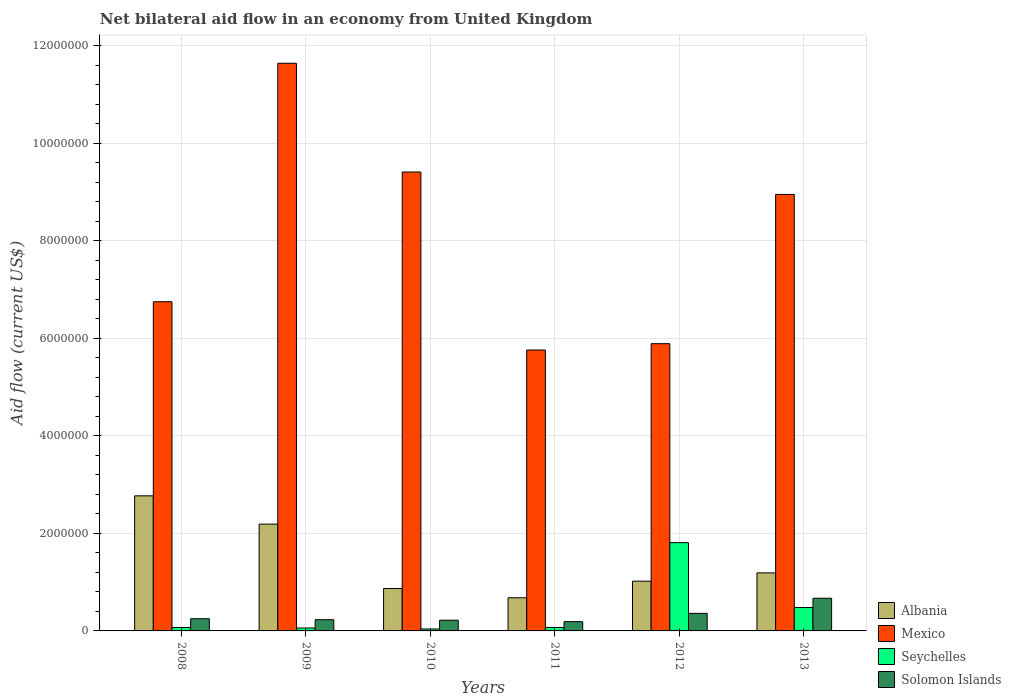How many different coloured bars are there?
Your response must be concise. 4. How many groups of bars are there?
Give a very brief answer. 6. Are the number of bars on each tick of the X-axis equal?
Your answer should be very brief. Yes. How many bars are there on the 3rd tick from the left?
Offer a very short reply. 4. What is the label of the 6th group of bars from the left?
Your answer should be compact. 2013. What is the net bilateral aid flow in Seychelles in 2012?
Give a very brief answer. 1.81e+06. Across all years, what is the maximum net bilateral aid flow in Albania?
Offer a very short reply. 2.77e+06. Across all years, what is the minimum net bilateral aid flow in Mexico?
Your answer should be compact. 5.76e+06. In which year was the net bilateral aid flow in Albania maximum?
Your answer should be very brief. 2008. What is the total net bilateral aid flow in Solomon Islands in the graph?
Your answer should be compact. 1.92e+06. What is the difference between the net bilateral aid flow in Seychelles in 2011 and the net bilateral aid flow in Solomon Islands in 2013?
Keep it short and to the point. -6.00e+05. What is the average net bilateral aid flow in Seychelles per year?
Offer a very short reply. 4.22e+05. What is the ratio of the net bilateral aid flow in Solomon Islands in 2008 to that in 2013?
Your answer should be very brief. 0.37. Is the net bilateral aid flow in Albania in 2008 less than that in 2010?
Your answer should be very brief. No. Is the difference between the net bilateral aid flow in Solomon Islands in 2009 and 2013 greater than the difference between the net bilateral aid flow in Seychelles in 2009 and 2013?
Keep it short and to the point. No. What is the difference between the highest and the second highest net bilateral aid flow in Seychelles?
Offer a terse response. 1.33e+06. What is the difference between the highest and the lowest net bilateral aid flow in Albania?
Your response must be concise. 2.09e+06. Is the sum of the net bilateral aid flow in Seychelles in 2009 and 2011 greater than the maximum net bilateral aid flow in Albania across all years?
Your response must be concise. No. Is it the case that in every year, the sum of the net bilateral aid flow in Solomon Islands and net bilateral aid flow in Albania is greater than the sum of net bilateral aid flow in Mexico and net bilateral aid flow in Seychelles?
Offer a terse response. Yes. What does the 3rd bar from the left in 2010 represents?
Provide a short and direct response. Seychelles. What does the 1st bar from the right in 2008 represents?
Offer a very short reply. Solomon Islands. What is the difference between two consecutive major ticks on the Y-axis?
Your answer should be compact. 2.00e+06. Does the graph contain any zero values?
Provide a succinct answer. No. Where does the legend appear in the graph?
Make the answer very short. Bottom right. What is the title of the graph?
Offer a very short reply. Net bilateral aid flow in an economy from United Kingdom. Does "Syrian Arab Republic" appear as one of the legend labels in the graph?
Your answer should be very brief. No. What is the label or title of the X-axis?
Your answer should be very brief. Years. What is the label or title of the Y-axis?
Your answer should be compact. Aid flow (current US$). What is the Aid flow (current US$) in Albania in 2008?
Make the answer very short. 2.77e+06. What is the Aid flow (current US$) of Mexico in 2008?
Give a very brief answer. 6.75e+06. What is the Aid flow (current US$) of Seychelles in 2008?
Give a very brief answer. 7.00e+04. What is the Aid flow (current US$) of Solomon Islands in 2008?
Make the answer very short. 2.50e+05. What is the Aid flow (current US$) of Albania in 2009?
Ensure brevity in your answer.  2.19e+06. What is the Aid flow (current US$) in Mexico in 2009?
Your answer should be very brief. 1.16e+07. What is the Aid flow (current US$) of Seychelles in 2009?
Provide a short and direct response. 6.00e+04. What is the Aid flow (current US$) in Solomon Islands in 2009?
Your answer should be compact. 2.30e+05. What is the Aid flow (current US$) in Albania in 2010?
Your answer should be compact. 8.70e+05. What is the Aid flow (current US$) in Mexico in 2010?
Make the answer very short. 9.41e+06. What is the Aid flow (current US$) in Albania in 2011?
Make the answer very short. 6.80e+05. What is the Aid flow (current US$) in Mexico in 2011?
Provide a short and direct response. 5.76e+06. What is the Aid flow (current US$) of Solomon Islands in 2011?
Provide a succinct answer. 1.90e+05. What is the Aid flow (current US$) of Albania in 2012?
Your answer should be very brief. 1.02e+06. What is the Aid flow (current US$) of Mexico in 2012?
Provide a short and direct response. 5.89e+06. What is the Aid flow (current US$) of Seychelles in 2012?
Provide a succinct answer. 1.81e+06. What is the Aid flow (current US$) in Solomon Islands in 2012?
Give a very brief answer. 3.60e+05. What is the Aid flow (current US$) in Albania in 2013?
Keep it short and to the point. 1.19e+06. What is the Aid flow (current US$) in Mexico in 2013?
Offer a terse response. 8.95e+06. What is the Aid flow (current US$) of Solomon Islands in 2013?
Provide a short and direct response. 6.70e+05. Across all years, what is the maximum Aid flow (current US$) in Albania?
Offer a terse response. 2.77e+06. Across all years, what is the maximum Aid flow (current US$) of Mexico?
Your response must be concise. 1.16e+07. Across all years, what is the maximum Aid flow (current US$) in Seychelles?
Make the answer very short. 1.81e+06. Across all years, what is the maximum Aid flow (current US$) of Solomon Islands?
Provide a short and direct response. 6.70e+05. Across all years, what is the minimum Aid flow (current US$) of Albania?
Your answer should be compact. 6.80e+05. Across all years, what is the minimum Aid flow (current US$) in Mexico?
Your answer should be compact. 5.76e+06. Across all years, what is the minimum Aid flow (current US$) in Seychelles?
Offer a terse response. 4.00e+04. Across all years, what is the minimum Aid flow (current US$) of Solomon Islands?
Give a very brief answer. 1.90e+05. What is the total Aid flow (current US$) in Albania in the graph?
Provide a short and direct response. 8.72e+06. What is the total Aid flow (current US$) of Mexico in the graph?
Your response must be concise. 4.84e+07. What is the total Aid flow (current US$) of Seychelles in the graph?
Give a very brief answer. 2.53e+06. What is the total Aid flow (current US$) in Solomon Islands in the graph?
Your answer should be compact. 1.92e+06. What is the difference between the Aid flow (current US$) of Albania in 2008 and that in 2009?
Your answer should be very brief. 5.80e+05. What is the difference between the Aid flow (current US$) of Mexico in 2008 and that in 2009?
Ensure brevity in your answer.  -4.89e+06. What is the difference between the Aid flow (current US$) of Seychelles in 2008 and that in 2009?
Provide a short and direct response. 10000. What is the difference between the Aid flow (current US$) of Solomon Islands in 2008 and that in 2009?
Provide a succinct answer. 2.00e+04. What is the difference between the Aid flow (current US$) in Albania in 2008 and that in 2010?
Ensure brevity in your answer.  1.90e+06. What is the difference between the Aid flow (current US$) in Mexico in 2008 and that in 2010?
Keep it short and to the point. -2.66e+06. What is the difference between the Aid flow (current US$) in Seychelles in 2008 and that in 2010?
Provide a succinct answer. 3.00e+04. What is the difference between the Aid flow (current US$) in Solomon Islands in 2008 and that in 2010?
Make the answer very short. 3.00e+04. What is the difference between the Aid flow (current US$) of Albania in 2008 and that in 2011?
Your answer should be very brief. 2.09e+06. What is the difference between the Aid flow (current US$) of Mexico in 2008 and that in 2011?
Provide a succinct answer. 9.90e+05. What is the difference between the Aid flow (current US$) in Seychelles in 2008 and that in 2011?
Give a very brief answer. 0. What is the difference between the Aid flow (current US$) in Solomon Islands in 2008 and that in 2011?
Keep it short and to the point. 6.00e+04. What is the difference between the Aid flow (current US$) of Albania in 2008 and that in 2012?
Offer a very short reply. 1.75e+06. What is the difference between the Aid flow (current US$) of Mexico in 2008 and that in 2012?
Your response must be concise. 8.60e+05. What is the difference between the Aid flow (current US$) in Seychelles in 2008 and that in 2012?
Give a very brief answer. -1.74e+06. What is the difference between the Aid flow (current US$) of Albania in 2008 and that in 2013?
Your response must be concise. 1.58e+06. What is the difference between the Aid flow (current US$) in Mexico in 2008 and that in 2013?
Keep it short and to the point. -2.20e+06. What is the difference between the Aid flow (current US$) in Seychelles in 2008 and that in 2013?
Make the answer very short. -4.10e+05. What is the difference between the Aid flow (current US$) of Solomon Islands in 2008 and that in 2013?
Offer a very short reply. -4.20e+05. What is the difference between the Aid flow (current US$) in Albania in 2009 and that in 2010?
Provide a short and direct response. 1.32e+06. What is the difference between the Aid flow (current US$) of Mexico in 2009 and that in 2010?
Keep it short and to the point. 2.23e+06. What is the difference between the Aid flow (current US$) in Albania in 2009 and that in 2011?
Provide a short and direct response. 1.51e+06. What is the difference between the Aid flow (current US$) of Mexico in 2009 and that in 2011?
Your answer should be very brief. 5.88e+06. What is the difference between the Aid flow (current US$) in Seychelles in 2009 and that in 2011?
Make the answer very short. -10000. What is the difference between the Aid flow (current US$) in Solomon Islands in 2009 and that in 2011?
Your response must be concise. 4.00e+04. What is the difference between the Aid flow (current US$) in Albania in 2009 and that in 2012?
Ensure brevity in your answer.  1.17e+06. What is the difference between the Aid flow (current US$) in Mexico in 2009 and that in 2012?
Your answer should be very brief. 5.75e+06. What is the difference between the Aid flow (current US$) in Seychelles in 2009 and that in 2012?
Offer a terse response. -1.75e+06. What is the difference between the Aid flow (current US$) in Solomon Islands in 2009 and that in 2012?
Provide a short and direct response. -1.30e+05. What is the difference between the Aid flow (current US$) of Albania in 2009 and that in 2013?
Your answer should be very brief. 1.00e+06. What is the difference between the Aid flow (current US$) in Mexico in 2009 and that in 2013?
Offer a very short reply. 2.69e+06. What is the difference between the Aid flow (current US$) of Seychelles in 2009 and that in 2013?
Give a very brief answer. -4.20e+05. What is the difference between the Aid flow (current US$) of Solomon Islands in 2009 and that in 2013?
Make the answer very short. -4.40e+05. What is the difference between the Aid flow (current US$) of Albania in 2010 and that in 2011?
Your response must be concise. 1.90e+05. What is the difference between the Aid flow (current US$) in Mexico in 2010 and that in 2011?
Provide a succinct answer. 3.65e+06. What is the difference between the Aid flow (current US$) of Seychelles in 2010 and that in 2011?
Ensure brevity in your answer.  -3.00e+04. What is the difference between the Aid flow (current US$) of Solomon Islands in 2010 and that in 2011?
Provide a short and direct response. 3.00e+04. What is the difference between the Aid flow (current US$) of Mexico in 2010 and that in 2012?
Offer a very short reply. 3.52e+06. What is the difference between the Aid flow (current US$) in Seychelles in 2010 and that in 2012?
Offer a terse response. -1.77e+06. What is the difference between the Aid flow (current US$) of Albania in 2010 and that in 2013?
Your response must be concise. -3.20e+05. What is the difference between the Aid flow (current US$) in Seychelles in 2010 and that in 2013?
Your response must be concise. -4.40e+05. What is the difference between the Aid flow (current US$) of Solomon Islands in 2010 and that in 2013?
Your answer should be very brief. -4.50e+05. What is the difference between the Aid flow (current US$) in Mexico in 2011 and that in 2012?
Your response must be concise. -1.30e+05. What is the difference between the Aid flow (current US$) in Seychelles in 2011 and that in 2012?
Provide a succinct answer. -1.74e+06. What is the difference between the Aid flow (current US$) in Solomon Islands in 2011 and that in 2012?
Provide a succinct answer. -1.70e+05. What is the difference between the Aid flow (current US$) of Albania in 2011 and that in 2013?
Your response must be concise. -5.10e+05. What is the difference between the Aid flow (current US$) in Mexico in 2011 and that in 2013?
Your answer should be very brief. -3.19e+06. What is the difference between the Aid flow (current US$) of Seychelles in 2011 and that in 2013?
Give a very brief answer. -4.10e+05. What is the difference between the Aid flow (current US$) in Solomon Islands in 2011 and that in 2013?
Your response must be concise. -4.80e+05. What is the difference between the Aid flow (current US$) in Mexico in 2012 and that in 2013?
Give a very brief answer. -3.06e+06. What is the difference between the Aid flow (current US$) of Seychelles in 2012 and that in 2013?
Give a very brief answer. 1.33e+06. What is the difference between the Aid flow (current US$) of Solomon Islands in 2012 and that in 2013?
Make the answer very short. -3.10e+05. What is the difference between the Aid flow (current US$) in Albania in 2008 and the Aid flow (current US$) in Mexico in 2009?
Ensure brevity in your answer.  -8.87e+06. What is the difference between the Aid flow (current US$) in Albania in 2008 and the Aid flow (current US$) in Seychelles in 2009?
Keep it short and to the point. 2.71e+06. What is the difference between the Aid flow (current US$) of Albania in 2008 and the Aid flow (current US$) of Solomon Islands in 2009?
Provide a succinct answer. 2.54e+06. What is the difference between the Aid flow (current US$) of Mexico in 2008 and the Aid flow (current US$) of Seychelles in 2009?
Offer a terse response. 6.69e+06. What is the difference between the Aid flow (current US$) in Mexico in 2008 and the Aid flow (current US$) in Solomon Islands in 2009?
Your answer should be very brief. 6.52e+06. What is the difference between the Aid flow (current US$) of Albania in 2008 and the Aid flow (current US$) of Mexico in 2010?
Keep it short and to the point. -6.64e+06. What is the difference between the Aid flow (current US$) of Albania in 2008 and the Aid flow (current US$) of Seychelles in 2010?
Offer a very short reply. 2.73e+06. What is the difference between the Aid flow (current US$) of Albania in 2008 and the Aid flow (current US$) of Solomon Islands in 2010?
Offer a terse response. 2.55e+06. What is the difference between the Aid flow (current US$) in Mexico in 2008 and the Aid flow (current US$) in Seychelles in 2010?
Your response must be concise. 6.71e+06. What is the difference between the Aid flow (current US$) of Mexico in 2008 and the Aid flow (current US$) of Solomon Islands in 2010?
Your response must be concise. 6.53e+06. What is the difference between the Aid flow (current US$) in Albania in 2008 and the Aid flow (current US$) in Mexico in 2011?
Your answer should be very brief. -2.99e+06. What is the difference between the Aid flow (current US$) in Albania in 2008 and the Aid flow (current US$) in Seychelles in 2011?
Your response must be concise. 2.70e+06. What is the difference between the Aid flow (current US$) of Albania in 2008 and the Aid flow (current US$) of Solomon Islands in 2011?
Provide a succinct answer. 2.58e+06. What is the difference between the Aid flow (current US$) of Mexico in 2008 and the Aid flow (current US$) of Seychelles in 2011?
Provide a succinct answer. 6.68e+06. What is the difference between the Aid flow (current US$) of Mexico in 2008 and the Aid flow (current US$) of Solomon Islands in 2011?
Make the answer very short. 6.56e+06. What is the difference between the Aid flow (current US$) in Albania in 2008 and the Aid flow (current US$) in Mexico in 2012?
Provide a succinct answer. -3.12e+06. What is the difference between the Aid flow (current US$) of Albania in 2008 and the Aid flow (current US$) of Seychelles in 2012?
Your response must be concise. 9.60e+05. What is the difference between the Aid flow (current US$) in Albania in 2008 and the Aid flow (current US$) in Solomon Islands in 2012?
Your response must be concise. 2.41e+06. What is the difference between the Aid flow (current US$) in Mexico in 2008 and the Aid flow (current US$) in Seychelles in 2012?
Your answer should be very brief. 4.94e+06. What is the difference between the Aid flow (current US$) of Mexico in 2008 and the Aid flow (current US$) of Solomon Islands in 2012?
Your answer should be compact. 6.39e+06. What is the difference between the Aid flow (current US$) in Seychelles in 2008 and the Aid flow (current US$) in Solomon Islands in 2012?
Provide a succinct answer. -2.90e+05. What is the difference between the Aid flow (current US$) in Albania in 2008 and the Aid flow (current US$) in Mexico in 2013?
Keep it short and to the point. -6.18e+06. What is the difference between the Aid flow (current US$) of Albania in 2008 and the Aid flow (current US$) of Seychelles in 2013?
Your answer should be compact. 2.29e+06. What is the difference between the Aid flow (current US$) in Albania in 2008 and the Aid flow (current US$) in Solomon Islands in 2013?
Ensure brevity in your answer.  2.10e+06. What is the difference between the Aid flow (current US$) in Mexico in 2008 and the Aid flow (current US$) in Seychelles in 2013?
Offer a very short reply. 6.27e+06. What is the difference between the Aid flow (current US$) in Mexico in 2008 and the Aid flow (current US$) in Solomon Islands in 2013?
Your response must be concise. 6.08e+06. What is the difference between the Aid flow (current US$) of Seychelles in 2008 and the Aid flow (current US$) of Solomon Islands in 2013?
Provide a short and direct response. -6.00e+05. What is the difference between the Aid flow (current US$) of Albania in 2009 and the Aid flow (current US$) of Mexico in 2010?
Keep it short and to the point. -7.22e+06. What is the difference between the Aid flow (current US$) of Albania in 2009 and the Aid flow (current US$) of Seychelles in 2010?
Keep it short and to the point. 2.15e+06. What is the difference between the Aid flow (current US$) of Albania in 2009 and the Aid flow (current US$) of Solomon Islands in 2010?
Your answer should be very brief. 1.97e+06. What is the difference between the Aid flow (current US$) of Mexico in 2009 and the Aid flow (current US$) of Seychelles in 2010?
Your answer should be compact. 1.16e+07. What is the difference between the Aid flow (current US$) in Mexico in 2009 and the Aid flow (current US$) in Solomon Islands in 2010?
Your answer should be compact. 1.14e+07. What is the difference between the Aid flow (current US$) in Seychelles in 2009 and the Aid flow (current US$) in Solomon Islands in 2010?
Give a very brief answer. -1.60e+05. What is the difference between the Aid flow (current US$) in Albania in 2009 and the Aid flow (current US$) in Mexico in 2011?
Make the answer very short. -3.57e+06. What is the difference between the Aid flow (current US$) of Albania in 2009 and the Aid flow (current US$) of Seychelles in 2011?
Your answer should be very brief. 2.12e+06. What is the difference between the Aid flow (current US$) of Mexico in 2009 and the Aid flow (current US$) of Seychelles in 2011?
Provide a succinct answer. 1.16e+07. What is the difference between the Aid flow (current US$) of Mexico in 2009 and the Aid flow (current US$) of Solomon Islands in 2011?
Provide a succinct answer. 1.14e+07. What is the difference between the Aid flow (current US$) of Albania in 2009 and the Aid flow (current US$) of Mexico in 2012?
Give a very brief answer. -3.70e+06. What is the difference between the Aid flow (current US$) in Albania in 2009 and the Aid flow (current US$) in Solomon Islands in 2012?
Give a very brief answer. 1.83e+06. What is the difference between the Aid flow (current US$) in Mexico in 2009 and the Aid flow (current US$) in Seychelles in 2012?
Ensure brevity in your answer.  9.83e+06. What is the difference between the Aid flow (current US$) of Mexico in 2009 and the Aid flow (current US$) of Solomon Islands in 2012?
Make the answer very short. 1.13e+07. What is the difference between the Aid flow (current US$) of Albania in 2009 and the Aid flow (current US$) of Mexico in 2013?
Give a very brief answer. -6.76e+06. What is the difference between the Aid flow (current US$) of Albania in 2009 and the Aid flow (current US$) of Seychelles in 2013?
Your answer should be compact. 1.71e+06. What is the difference between the Aid flow (current US$) of Albania in 2009 and the Aid flow (current US$) of Solomon Islands in 2013?
Offer a very short reply. 1.52e+06. What is the difference between the Aid flow (current US$) in Mexico in 2009 and the Aid flow (current US$) in Seychelles in 2013?
Your answer should be very brief. 1.12e+07. What is the difference between the Aid flow (current US$) in Mexico in 2009 and the Aid flow (current US$) in Solomon Islands in 2013?
Give a very brief answer. 1.10e+07. What is the difference between the Aid flow (current US$) of Seychelles in 2009 and the Aid flow (current US$) of Solomon Islands in 2013?
Your answer should be compact. -6.10e+05. What is the difference between the Aid flow (current US$) of Albania in 2010 and the Aid flow (current US$) of Mexico in 2011?
Ensure brevity in your answer.  -4.89e+06. What is the difference between the Aid flow (current US$) of Albania in 2010 and the Aid flow (current US$) of Solomon Islands in 2011?
Offer a terse response. 6.80e+05. What is the difference between the Aid flow (current US$) of Mexico in 2010 and the Aid flow (current US$) of Seychelles in 2011?
Your answer should be very brief. 9.34e+06. What is the difference between the Aid flow (current US$) in Mexico in 2010 and the Aid flow (current US$) in Solomon Islands in 2011?
Your response must be concise. 9.22e+06. What is the difference between the Aid flow (current US$) in Albania in 2010 and the Aid flow (current US$) in Mexico in 2012?
Give a very brief answer. -5.02e+06. What is the difference between the Aid flow (current US$) of Albania in 2010 and the Aid flow (current US$) of Seychelles in 2012?
Your response must be concise. -9.40e+05. What is the difference between the Aid flow (current US$) of Albania in 2010 and the Aid flow (current US$) of Solomon Islands in 2012?
Keep it short and to the point. 5.10e+05. What is the difference between the Aid flow (current US$) in Mexico in 2010 and the Aid flow (current US$) in Seychelles in 2012?
Provide a succinct answer. 7.60e+06. What is the difference between the Aid flow (current US$) in Mexico in 2010 and the Aid flow (current US$) in Solomon Islands in 2012?
Your answer should be compact. 9.05e+06. What is the difference between the Aid flow (current US$) of Seychelles in 2010 and the Aid flow (current US$) of Solomon Islands in 2012?
Keep it short and to the point. -3.20e+05. What is the difference between the Aid flow (current US$) in Albania in 2010 and the Aid flow (current US$) in Mexico in 2013?
Provide a short and direct response. -8.08e+06. What is the difference between the Aid flow (current US$) of Albania in 2010 and the Aid flow (current US$) of Seychelles in 2013?
Provide a succinct answer. 3.90e+05. What is the difference between the Aid flow (current US$) in Mexico in 2010 and the Aid flow (current US$) in Seychelles in 2013?
Make the answer very short. 8.93e+06. What is the difference between the Aid flow (current US$) of Mexico in 2010 and the Aid flow (current US$) of Solomon Islands in 2013?
Offer a very short reply. 8.74e+06. What is the difference between the Aid flow (current US$) in Seychelles in 2010 and the Aid flow (current US$) in Solomon Islands in 2013?
Your answer should be compact. -6.30e+05. What is the difference between the Aid flow (current US$) in Albania in 2011 and the Aid flow (current US$) in Mexico in 2012?
Offer a very short reply. -5.21e+06. What is the difference between the Aid flow (current US$) of Albania in 2011 and the Aid flow (current US$) of Seychelles in 2012?
Offer a very short reply. -1.13e+06. What is the difference between the Aid flow (current US$) in Mexico in 2011 and the Aid flow (current US$) in Seychelles in 2012?
Your answer should be very brief. 3.95e+06. What is the difference between the Aid flow (current US$) in Mexico in 2011 and the Aid flow (current US$) in Solomon Islands in 2012?
Ensure brevity in your answer.  5.40e+06. What is the difference between the Aid flow (current US$) in Seychelles in 2011 and the Aid flow (current US$) in Solomon Islands in 2012?
Ensure brevity in your answer.  -2.90e+05. What is the difference between the Aid flow (current US$) in Albania in 2011 and the Aid flow (current US$) in Mexico in 2013?
Ensure brevity in your answer.  -8.27e+06. What is the difference between the Aid flow (current US$) in Mexico in 2011 and the Aid flow (current US$) in Seychelles in 2013?
Your response must be concise. 5.28e+06. What is the difference between the Aid flow (current US$) of Mexico in 2011 and the Aid flow (current US$) of Solomon Islands in 2013?
Make the answer very short. 5.09e+06. What is the difference between the Aid flow (current US$) of Seychelles in 2011 and the Aid flow (current US$) of Solomon Islands in 2013?
Provide a short and direct response. -6.00e+05. What is the difference between the Aid flow (current US$) in Albania in 2012 and the Aid flow (current US$) in Mexico in 2013?
Provide a succinct answer. -7.93e+06. What is the difference between the Aid flow (current US$) of Albania in 2012 and the Aid flow (current US$) of Seychelles in 2013?
Provide a short and direct response. 5.40e+05. What is the difference between the Aid flow (current US$) of Albania in 2012 and the Aid flow (current US$) of Solomon Islands in 2013?
Give a very brief answer. 3.50e+05. What is the difference between the Aid flow (current US$) in Mexico in 2012 and the Aid flow (current US$) in Seychelles in 2013?
Provide a short and direct response. 5.41e+06. What is the difference between the Aid flow (current US$) of Mexico in 2012 and the Aid flow (current US$) of Solomon Islands in 2013?
Your answer should be very brief. 5.22e+06. What is the difference between the Aid flow (current US$) in Seychelles in 2012 and the Aid flow (current US$) in Solomon Islands in 2013?
Offer a terse response. 1.14e+06. What is the average Aid flow (current US$) in Albania per year?
Your response must be concise. 1.45e+06. What is the average Aid flow (current US$) in Mexico per year?
Your answer should be compact. 8.07e+06. What is the average Aid flow (current US$) of Seychelles per year?
Offer a very short reply. 4.22e+05. In the year 2008, what is the difference between the Aid flow (current US$) of Albania and Aid flow (current US$) of Mexico?
Offer a very short reply. -3.98e+06. In the year 2008, what is the difference between the Aid flow (current US$) of Albania and Aid flow (current US$) of Seychelles?
Your answer should be compact. 2.70e+06. In the year 2008, what is the difference between the Aid flow (current US$) in Albania and Aid flow (current US$) in Solomon Islands?
Your answer should be very brief. 2.52e+06. In the year 2008, what is the difference between the Aid flow (current US$) of Mexico and Aid flow (current US$) of Seychelles?
Keep it short and to the point. 6.68e+06. In the year 2008, what is the difference between the Aid flow (current US$) of Mexico and Aid flow (current US$) of Solomon Islands?
Keep it short and to the point. 6.50e+06. In the year 2008, what is the difference between the Aid flow (current US$) of Seychelles and Aid flow (current US$) of Solomon Islands?
Provide a short and direct response. -1.80e+05. In the year 2009, what is the difference between the Aid flow (current US$) of Albania and Aid flow (current US$) of Mexico?
Ensure brevity in your answer.  -9.45e+06. In the year 2009, what is the difference between the Aid flow (current US$) in Albania and Aid flow (current US$) in Seychelles?
Your answer should be compact. 2.13e+06. In the year 2009, what is the difference between the Aid flow (current US$) of Albania and Aid flow (current US$) of Solomon Islands?
Ensure brevity in your answer.  1.96e+06. In the year 2009, what is the difference between the Aid flow (current US$) of Mexico and Aid flow (current US$) of Seychelles?
Your answer should be compact. 1.16e+07. In the year 2009, what is the difference between the Aid flow (current US$) of Mexico and Aid flow (current US$) of Solomon Islands?
Your answer should be very brief. 1.14e+07. In the year 2010, what is the difference between the Aid flow (current US$) in Albania and Aid flow (current US$) in Mexico?
Your response must be concise. -8.54e+06. In the year 2010, what is the difference between the Aid flow (current US$) in Albania and Aid flow (current US$) in Seychelles?
Offer a very short reply. 8.30e+05. In the year 2010, what is the difference between the Aid flow (current US$) in Albania and Aid flow (current US$) in Solomon Islands?
Give a very brief answer. 6.50e+05. In the year 2010, what is the difference between the Aid flow (current US$) of Mexico and Aid flow (current US$) of Seychelles?
Offer a very short reply. 9.37e+06. In the year 2010, what is the difference between the Aid flow (current US$) in Mexico and Aid flow (current US$) in Solomon Islands?
Offer a very short reply. 9.19e+06. In the year 2010, what is the difference between the Aid flow (current US$) in Seychelles and Aid flow (current US$) in Solomon Islands?
Your response must be concise. -1.80e+05. In the year 2011, what is the difference between the Aid flow (current US$) of Albania and Aid flow (current US$) of Mexico?
Offer a very short reply. -5.08e+06. In the year 2011, what is the difference between the Aid flow (current US$) of Albania and Aid flow (current US$) of Seychelles?
Provide a short and direct response. 6.10e+05. In the year 2011, what is the difference between the Aid flow (current US$) in Mexico and Aid flow (current US$) in Seychelles?
Make the answer very short. 5.69e+06. In the year 2011, what is the difference between the Aid flow (current US$) in Mexico and Aid flow (current US$) in Solomon Islands?
Make the answer very short. 5.57e+06. In the year 2012, what is the difference between the Aid flow (current US$) in Albania and Aid flow (current US$) in Mexico?
Ensure brevity in your answer.  -4.87e+06. In the year 2012, what is the difference between the Aid flow (current US$) of Albania and Aid flow (current US$) of Seychelles?
Provide a short and direct response. -7.90e+05. In the year 2012, what is the difference between the Aid flow (current US$) in Mexico and Aid flow (current US$) in Seychelles?
Keep it short and to the point. 4.08e+06. In the year 2012, what is the difference between the Aid flow (current US$) of Mexico and Aid flow (current US$) of Solomon Islands?
Keep it short and to the point. 5.53e+06. In the year 2012, what is the difference between the Aid flow (current US$) in Seychelles and Aid flow (current US$) in Solomon Islands?
Offer a very short reply. 1.45e+06. In the year 2013, what is the difference between the Aid flow (current US$) of Albania and Aid flow (current US$) of Mexico?
Provide a short and direct response. -7.76e+06. In the year 2013, what is the difference between the Aid flow (current US$) in Albania and Aid flow (current US$) in Seychelles?
Provide a short and direct response. 7.10e+05. In the year 2013, what is the difference between the Aid flow (current US$) of Albania and Aid flow (current US$) of Solomon Islands?
Your answer should be compact. 5.20e+05. In the year 2013, what is the difference between the Aid flow (current US$) in Mexico and Aid flow (current US$) in Seychelles?
Make the answer very short. 8.47e+06. In the year 2013, what is the difference between the Aid flow (current US$) of Mexico and Aid flow (current US$) of Solomon Islands?
Offer a very short reply. 8.28e+06. What is the ratio of the Aid flow (current US$) in Albania in 2008 to that in 2009?
Give a very brief answer. 1.26. What is the ratio of the Aid flow (current US$) of Mexico in 2008 to that in 2009?
Offer a very short reply. 0.58. What is the ratio of the Aid flow (current US$) in Solomon Islands in 2008 to that in 2009?
Your response must be concise. 1.09. What is the ratio of the Aid flow (current US$) in Albania in 2008 to that in 2010?
Your response must be concise. 3.18. What is the ratio of the Aid flow (current US$) in Mexico in 2008 to that in 2010?
Provide a succinct answer. 0.72. What is the ratio of the Aid flow (current US$) of Solomon Islands in 2008 to that in 2010?
Ensure brevity in your answer.  1.14. What is the ratio of the Aid flow (current US$) in Albania in 2008 to that in 2011?
Offer a very short reply. 4.07. What is the ratio of the Aid flow (current US$) in Mexico in 2008 to that in 2011?
Your response must be concise. 1.17. What is the ratio of the Aid flow (current US$) of Solomon Islands in 2008 to that in 2011?
Your answer should be very brief. 1.32. What is the ratio of the Aid flow (current US$) of Albania in 2008 to that in 2012?
Offer a terse response. 2.72. What is the ratio of the Aid flow (current US$) in Mexico in 2008 to that in 2012?
Offer a very short reply. 1.15. What is the ratio of the Aid flow (current US$) of Seychelles in 2008 to that in 2012?
Make the answer very short. 0.04. What is the ratio of the Aid flow (current US$) of Solomon Islands in 2008 to that in 2012?
Keep it short and to the point. 0.69. What is the ratio of the Aid flow (current US$) of Albania in 2008 to that in 2013?
Provide a succinct answer. 2.33. What is the ratio of the Aid flow (current US$) of Mexico in 2008 to that in 2013?
Your answer should be compact. 0.75. What is the ratio of the Aid flow (current US$) of Seychelles in 2008 to that in 2013?
Your response must be concise. 0.15. What is the ratio of the Aid flow (current US$) of Solomon Islands in 2008 to that in 2013?
Your answer should be compact. 0.37. What is the ratio of the Aid flow (current US$) in Albania in 2009 to that in 2010?
Your response must be concise. 2.52. What is the ratio of the Aid flow (current US$) of Mexico in 2009 to that in 2010?
Provide a short and direct response. 1.24. What is the ratio of the Aid flow (current US$) in Solomon Islands in 2009 to that in 2010?
Give a very brief answer. 1.05. What is the ratio of the Aid flow (current US$) in Albania in 2009 to that in 2011?
Your response must be concise. 3.22. What is the ratio of the Aid flow (current US$) in Mexico in 2009 to that in 2011?
Provide a succinct answer. 2.02. What is the ratio of the Aid flow (current US$) in Solomon Islands in 2009 to that in 2011?
Make the answer very short. 1.21. What is the ratio of the Aid flow (current US$) in Albania in 2009 to that in 2012?
Ensure brevity in your answer.  2.15. What is the ratio of the Aid flow (current US$) in Mexico in 2009 to that in 2012?
Your response must be concise. 1.98. What is the ratio of the Aid flow (current US$) of Seychelles in 2009 to that in 2012?
Provide a short and direct response. 0.03. What is the ratio of the Aid flow (current US$) in Solomon Islands in 2009 to that in 2012?
Provide a short and direct response. 0.64. What is the ratio of the Aid flow (current US$) in Albania in 2009 to that in 2013?
Provide a short and direct response. 1.84. What is the ratio of the Aid flow (current US$) in Mexico in 2009 to that in 2013?
Ensure brevity in your answer.  1.3. What is the ratio of the Aid flow (current US$) in Seychelles in 2009 to that in 2013?
Keep it short and to the point. 0.12. What is the ratio of the Aid flow (current US$) in Solomon Islands in 2009 to that in 2013?
Ensure brevity in your answer.  0.34. What is the ratio of the Aid flow (current US$) of Albania in 2010 to that in 2011?
Offer a very short reply. 1.28. What is the ratio of the Aid flow (current US$) of Mexico in 2010 to that in 2011?
Your response must be concise. 1.63. What is the ratio of the Aid flow (current US$) of Solomon Islands in 2010 to that in 2011?
Offer a very short reply. 1.16. What is the ratio of the Aid flow (current US$) of Albania in 2010 to that in 2012?
Ensure brevity in your answer.  0.85. What is the ratio of the Aid flow (current US$) of Mexico in 2010 to that in 2012?
Offer a terse response. 1.6. What is the ratio of the Aid flow (current US$) of Seychelles in 2010 to that in 2012?
Give a very brief answer. 0.02. What is the ratio of the Aid flow (current US$) of Solomon Islands in 2010 to that in 2012?
Your response must be concise. 0.61. What is the ratio of the Aid flow (current US$) of Albania in 2010 to that in 2013?
Ensure brevity in your answer.  0.73. What is the ratio of the Aid flow (current US$) in Mexico in 2010 to that in 2013?
Your answer should be very brief. 1.05. What is the ratio of the Aid flow (current US$) of Seychelles in 2010 to that in 2013?
Your answer should be compact. 0.08. What is the ratio of the Aid flow (current US$) in Solomon Islands in 2010 to that in 2013?
Give a very brief answer. 0.33. What is the ratio of the Aid flow (current US$) of Mexico in 2011 to that in 2012?
Your answer should be compact. 0.98. What is the ratio of the Aid flow (current US$) of Seychelles in 2011 to that in 2012?
Ensure brevity in your answer.  0.04. What is the ratio of the Aid flow (current US$) in Solomon Islands in 2011 to that in 2012?
Keep it short and to the point. 0.53. What is the ratio of the Aid flow (current US$) in Mexico in 2011 to that in 2013?
Give a very brief answer. 0.64. What is the ratio of the Aid flow (current US$) of Seychelles in 2011 to that in 2013?
Keep it short and to the point. 0.15. What is the ratio of the Aid flow (current US$) of Solomon Islands in 2011 to that in 2013?
Provide a succinct answer. 0.28. What is the ratio of the Aid flow (current US$) in Mexico in 2012 to that in 2013?
Give a very brief answer. 0.66. What is the ratio of the Aid flow (current US$) of Seychelles in 2012 to that in 2013?
Your answer should be compact. 3.77. What is the ratio of the Aid flow (current US$) in Solomon Islands in 2012 to that in 2013?
Offer a very short reply. 0.54. What is the difference between the highest and the second highest Aid flow (current US$) in Albania?
Your answer should be very brief. 5.80e+05. What is the difference between the highest and the second highest Aid flow (current US$) of Mexico?
Make the answer very short. 2.23e+06. What is the difference between the highest and the second highest Aid flow (current US$) in Seychelles?
Give a very brief answer. 1.33e+06. What is the difference between the highest and the lowest Aid flow (current US$) of Albania?
Offer a very short reply. 2.09e+06. What is the difference between the highest and the lowest Aid flow (current US$) in Mexico?
Your response must be concise. 5.88e+06. What is the difference between the highest and the lowest Aid flow (current US$) of Seychelles?
Provide a succinct answer. 1.77e+06. 